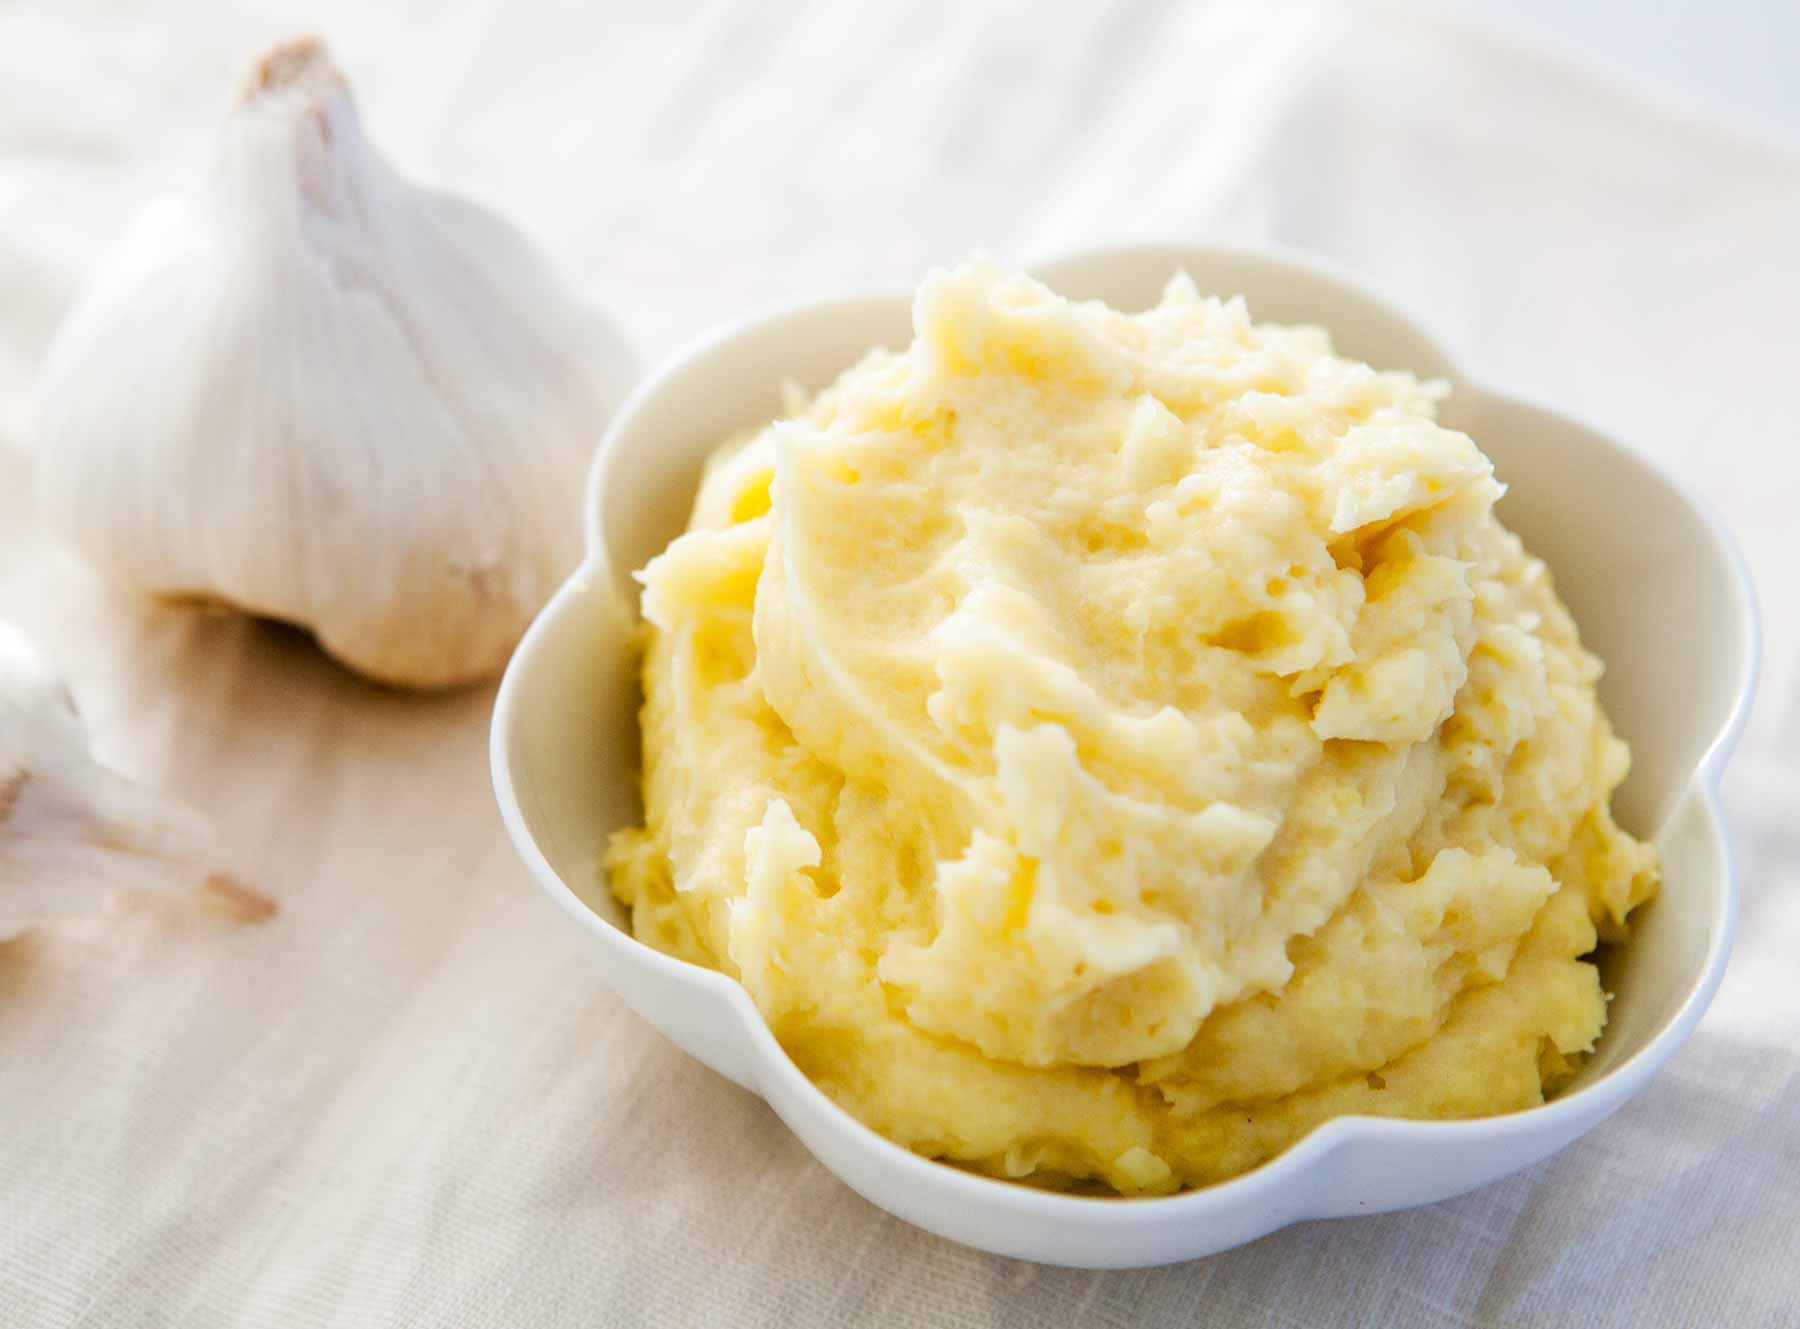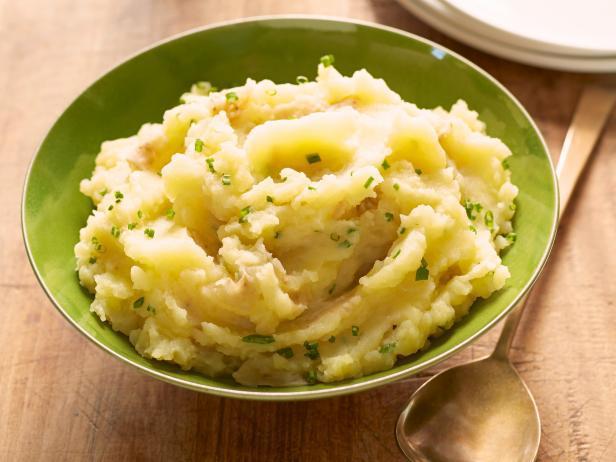The first image is the image on the left, the second image is the image on the right. Evaluate the accuracy of this statement regarding the images: "There is a green additive to the bowl on the right, such as parsley.". Is it true? Answer yes or no. Yes. The first image is the image on the left, the second image is the image on the right. Examine the images to the left and right. Is the description "A utensil with a handle is in one round bowl of mashed potatoes." accurate? Answer yes or no. No. 